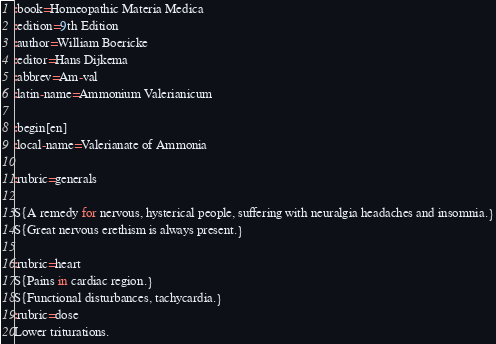Convert code to text. <code><loc_0><loc_0><loc_500><loc_500><_ObjectiveC_>:book=Homeopathic Materia Medica
:edition=9th Edition
:author=William Boericke
:editor=Hans Dijkema
:abbrev=Am-val
:latin-name=Ammonium Valerianicum

:begin[en]
:local-name=Valerianate of Ammonia

:rubric=generals

S{A remedy for nervous, hysterical people, suffering with neuralgia headaches and insomnia.}
S{Great nervous erethism is always present.}

:rubric=heart
S{Pains in cardiac region.}
S{Functional disturbances, tachycardia.}
:rubric=dose
Lower triturations.</code> 